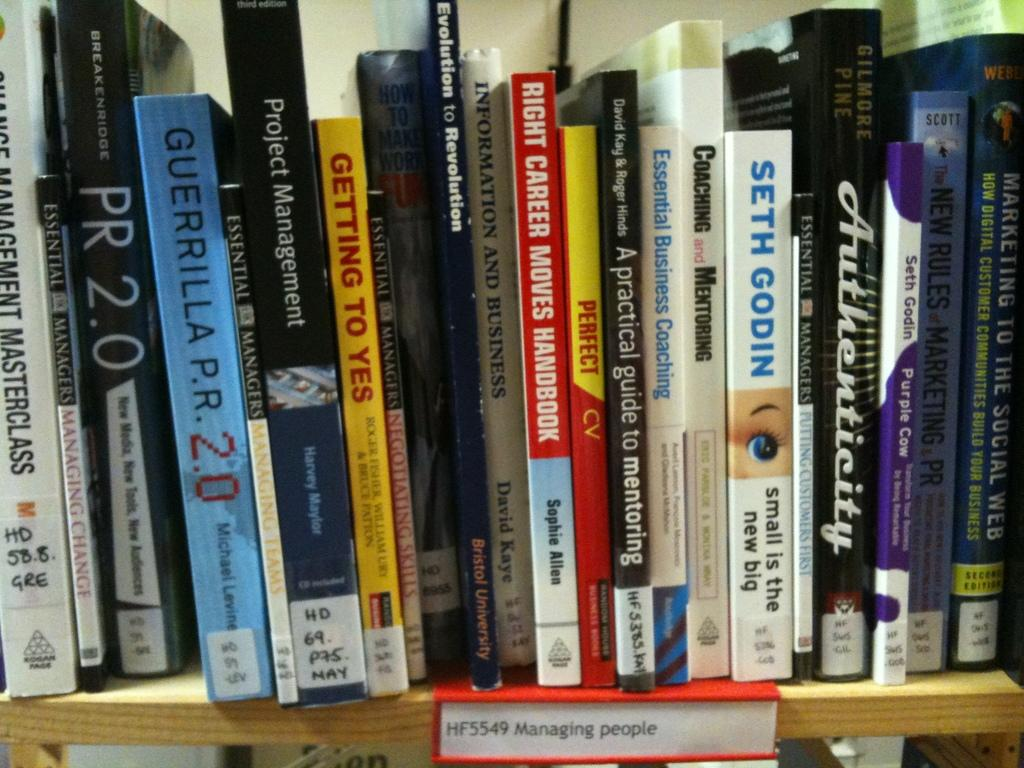Provide a one-sentence caption for the provided image. The bookshelf is the section to go to if you want to find a book about managing people. 